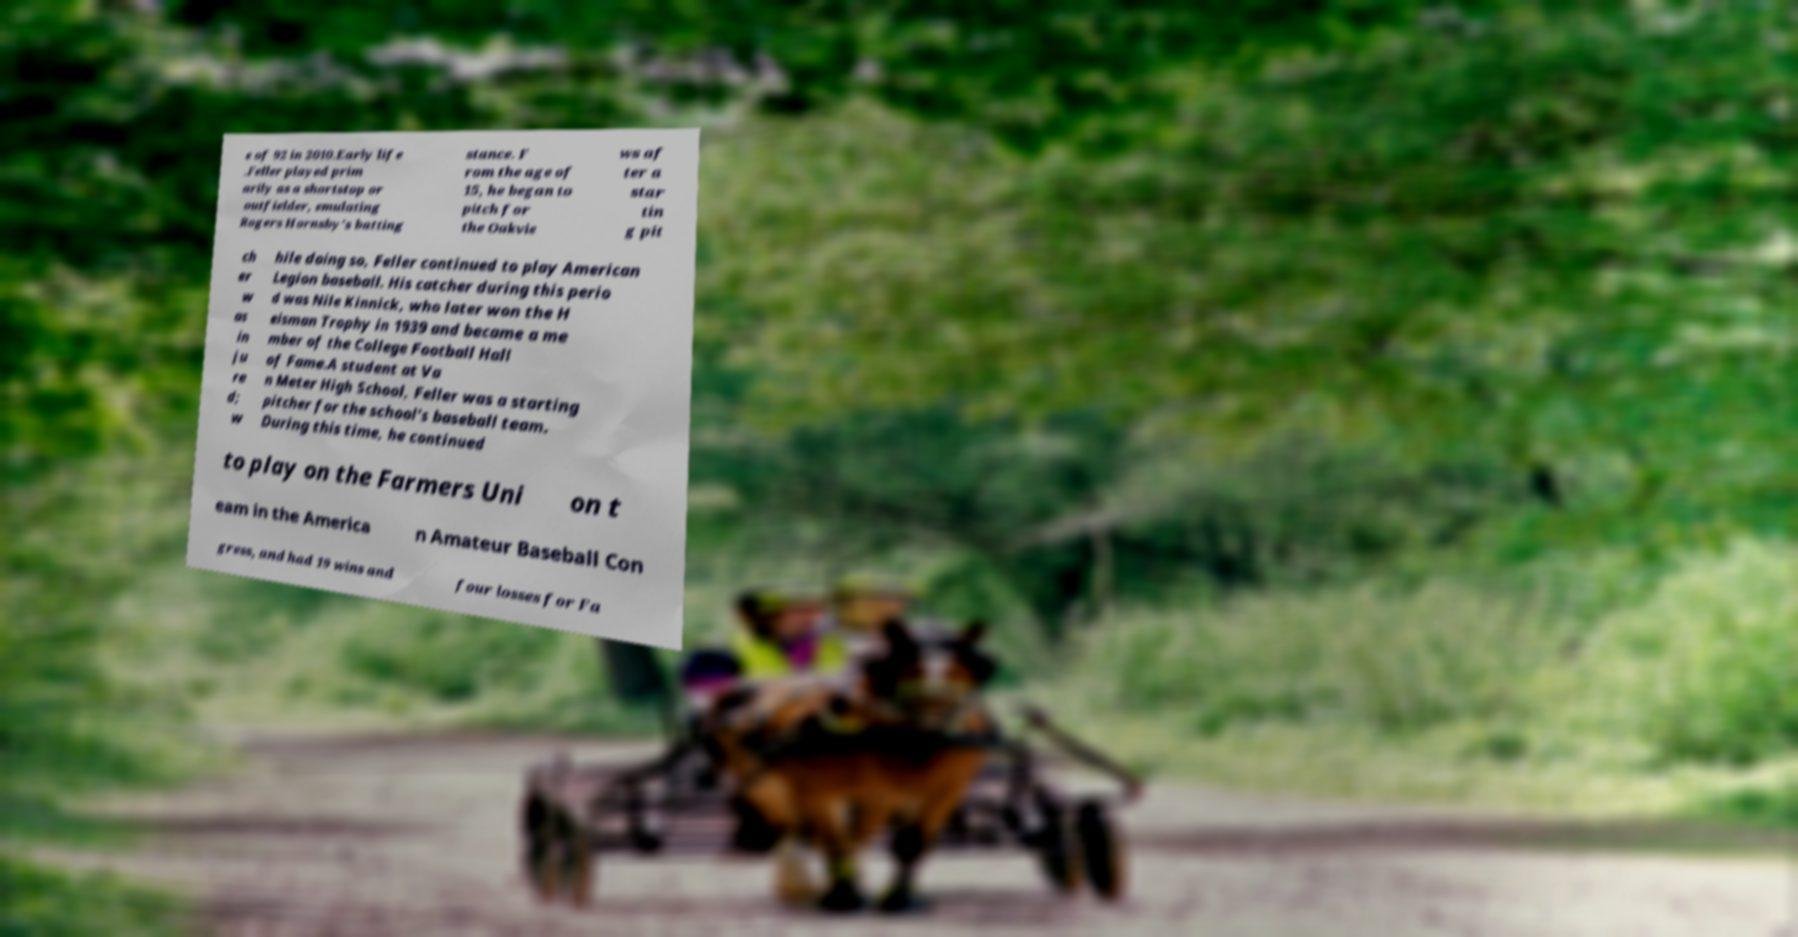Could you assist in decoding the text presented in this image and type it out clearly? e of 92 in 2010.Early life .Feller played prim arily as a shortstop or outfielder, emulating Rogers Hornsby's batting stance. F rom the age of 15, he began to pitch for the Oakvie ws af ter a star tin g pit ch er w as in ju re d; w hile doing so, Feller continued to play American Legion baseball. His catcher during this perio d was Nile Kinnick, who later won the H eisman Trophy in 1939 and became a me mber of the College Football Hall of Fame.A student at Va n Meter High School, Feller was a starting pitcher for the school's baseball team. During this time, he continued to play on the Farmers Uni on t eam in the America n Amateur Baseball Con gress, and had 19 wins and four losses for Fa 